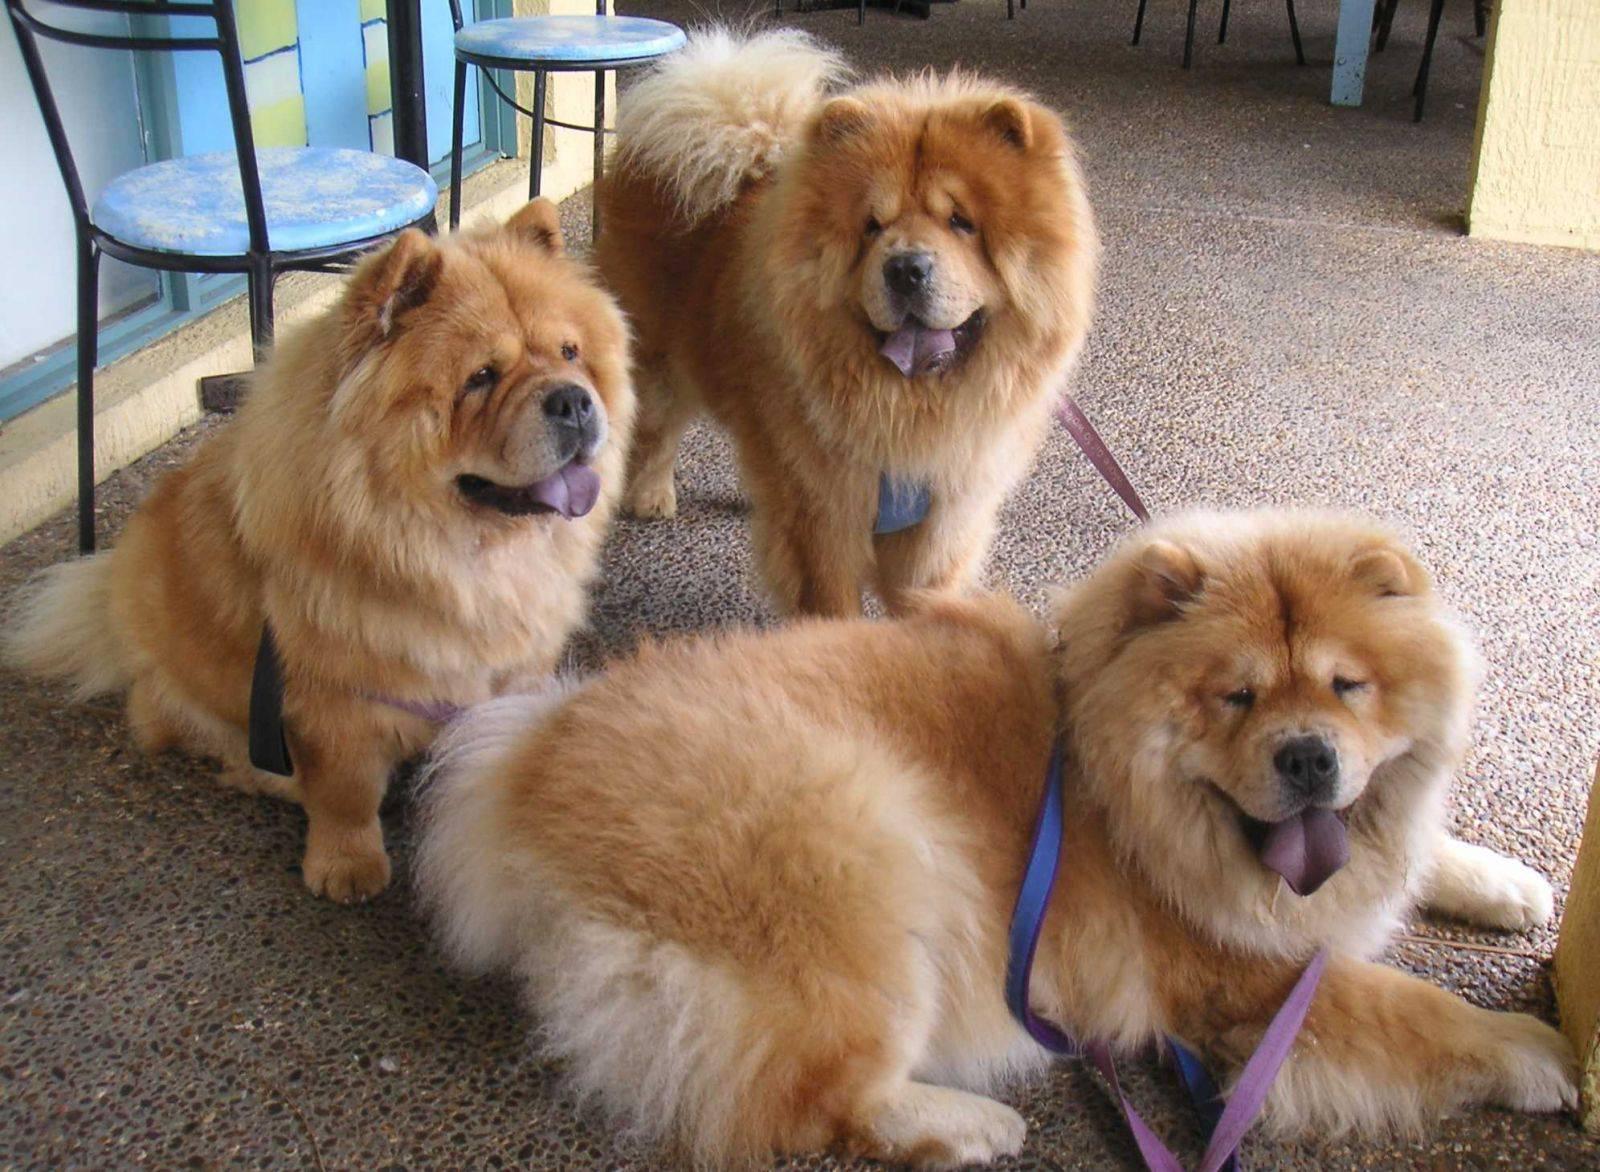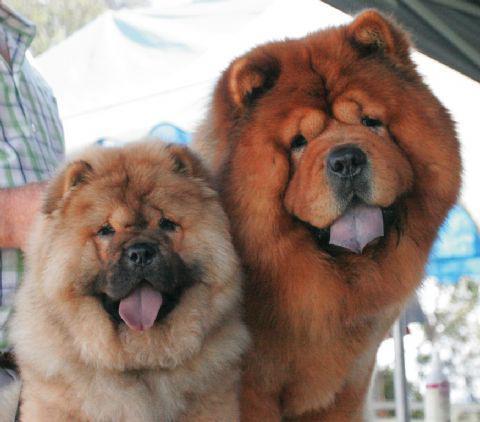The first image is the image on the left, the second image is the image on the right. Assess this claim about the two images: "There are no less than three dogs". Correct or not? Answer yes or no. Yes. The first image is the image on the left, the second image is the image on the right. Assess this claim about the two images: "There are at least two dogs in the image on the left.". Correct or not? Answer yes or no. Yes. 